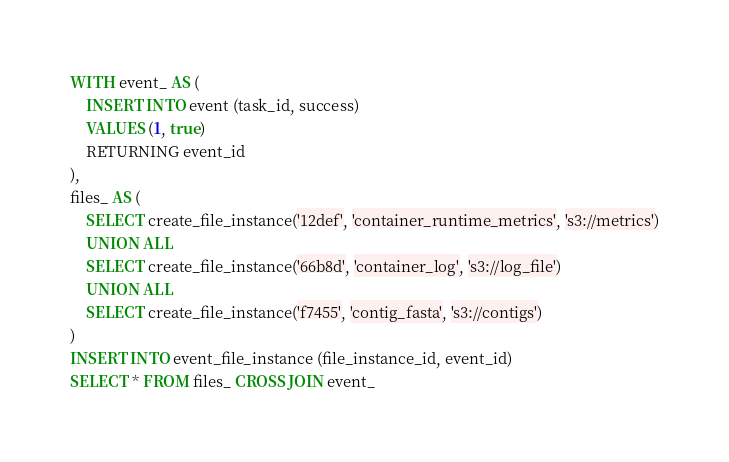<code> <loc_0><loc_0><loc_500><loc_500><_SQL_>WITH event_ AS (
	INSERT INTO event (task_id, success)
	VALUES (1, true)
	RETURNING event_id
),
files_ AS (
	SELECT create_file_instance('12def', 'container_runtime_metrics', 's3://metrics')
	UNION ALL
	SELECT create_file_instance('66b8d', 'container_log', 's3://log_file')
	UNION ALL
	SELECT create_file_instance('f7455', 'contig_fasta', 's3://contigs')
)
INSERT INTO event_file_instance (file_instance_id, event_id)
SELECT * FROM files_ CROSS JOIN event_
</code> 